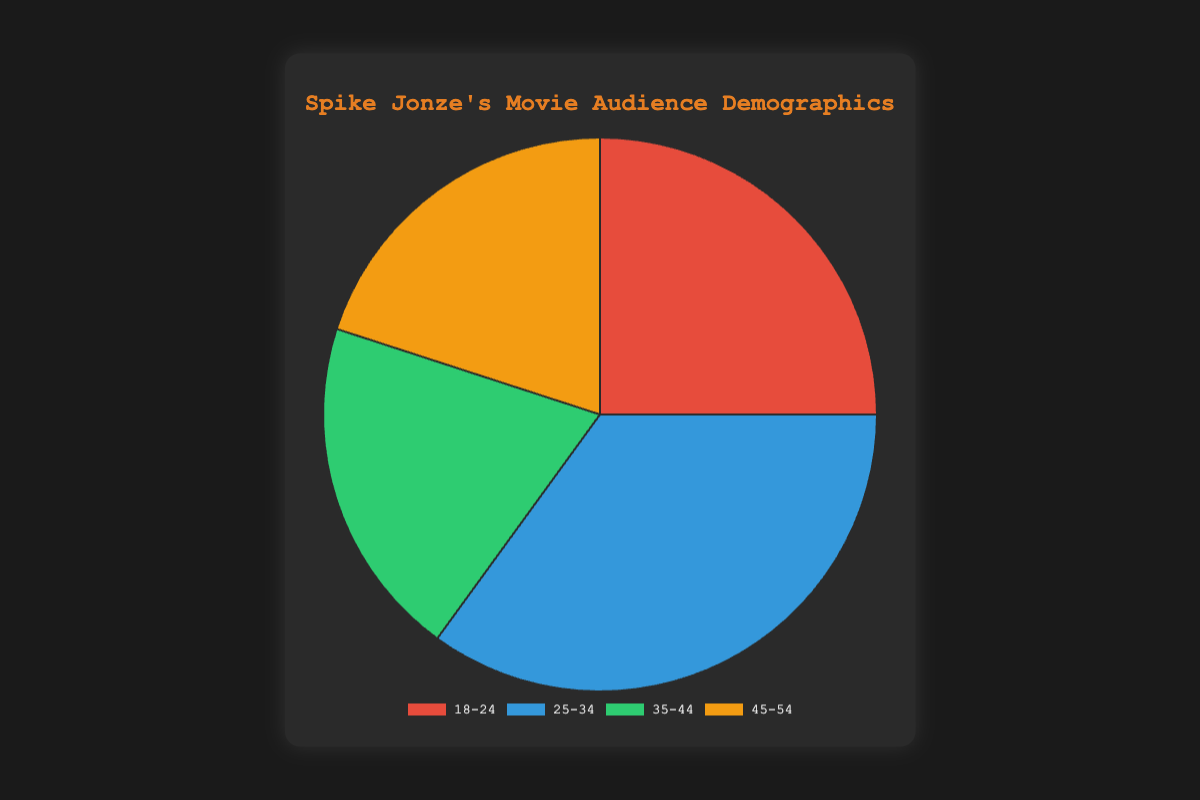Which age group has the highest percentage of the audience? The figure shows four age groups: 18-24, 25-34, 35-44, and 45-54 with their respective percentages. The 25-34 age group shows the highest percentage of 35%.
Answer: 25-34 Which age groups have the same percentage of the audience? By looking at the figure, the 35-44 and 45-54 age groups both have a percentage of 20%.
Answer: 35-44 and 45-54 What is the total percentage of the audiences aged 35-54? The age groups 35-44 and 45-54 have percentages of 20% each. The total percentage is 20% + 20% = 40%.
Answer: 40% How does the percentage of the 25-34 age group compare to the 18-24 age group? The 25-34 age group has 35%, whereas the 18-24 age group has 25%. The 25-34 age group has 10% more than the 18-24 age group.
Answer: 10% more What is the average percentage of the audiences across all age groups? Sum the percentages of all age groups (25% + 35% + 20% + 20%) which equals 100%. The average percentage is 100% divided by 4 age groups, resulting in 25%.
Answer: 25% What percentage of the audience is aged 18-34? The age groups 18-24 and 25-34 are within 18-34. Their percentages are 25% and 35% respectively. The total is 25% + 35% = 60%.
Answer: 60% By how much does the percentage of the 25-34 age group exceed the smallest percentage age groups? The smallest percentage age groups are 35-44 and 45-54, both at 20%. The 25-34 age group is at 35%, so it exceeds the smallest by 35% - 20% = 15%.
Answer: 15% Which color represents the 45-54 age group on the chart? The chart shows different colors for each age group. The 45-54 age group is represented by the orange color.
Answer: Orange If the 25-34 age group increased by 10%, what would be the new percentage and how would it compare to the 18-24 age group? Initially, the 25-34 age group is at 35%. An increase of 10% makes it 35% + 10% = 45%. Compared to the 18-24 age group, which is at 25%, the new percentage would be 45% - 25% = 20% higher.
Answer: 45%, 20% higher 